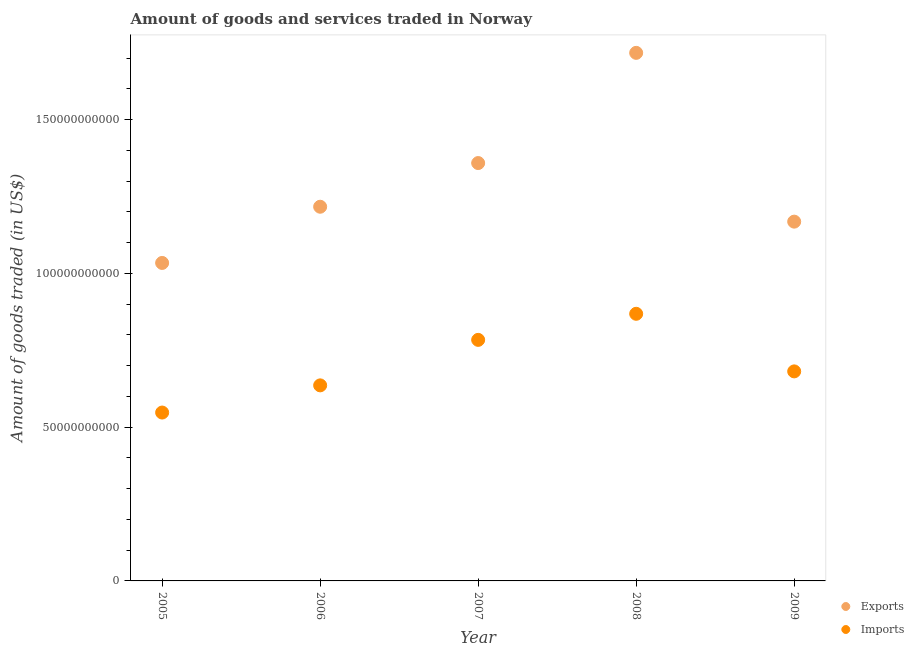How many different coloured dotlines are there?
Keep it short and to the point. 2. Is the number of dotlines equal to the number of legend labels?
Offer a terse response. Yes. What is the amount of goods imported in 2009?
Provide a short and direct response. 6.81e+1. Across all years, what is the maximum amount of goods exported?
Provide a short and direct response. 1.72e+11. Across all years, what is the minimum amount of goods exported?
Keep it short and to the point. 1.03e+11. In which year was the amount of goods imported maximum?
Your answer should be compact. 2008. In which year was the amount of goods exported minimum?
Ensure brevity in your answer.  2005. What is the total amount of goods exported in the graph?
Your response must be concise. 6.49e+11. What is the difference between the amount of goods exported in 2005 and that in 2006?
Offer a very short reply. -1.83e+1. What is the difference between the amount of goods exported in 2007 and the amount of goods imported in 2009?
Provide a succinct answer. 6.77e+1. What is the average amount of goods imported per year?
Provide a succinct answer. 7.03e+1. In the year 2005, what is the difference between the amount of goods exported and amount of goods imported?
Give a very brief answer. 4.86e+1. In how many years, is the amount of goods imported greater than 60000000000 US$?
Provide a short and direct response. 4. What is the ratio of the amount of goods imported in 2005 to that in 2008?
Your answer should be compact. 0.63. Is the amount of goods exported in 2005 less than that in 2009?
Give a very brief answer. Yes. What is the difference between the highest and the second highest amount of goods exported?
Offer a terse response. 3.58e+1. What is the difference between the highest and the lowest amount of goods exported?
Your answer should be compact. 6.83e+1. In how many years, is the amount of goods exported greater than the average amount of goods exported taken over all years?
Give a very brief answer. 2. Is the sum of the amount of goods exported in 2008 and 2009 greater than the maximum amount of goods imported across all years?
Make the answer very short. Yes. Is the amount of goods exported strictly greater than the amount of goods imported over the years?
Keep it short and to the point. Yes. Is the amount of goods imported strictly less than the amount of goods exported over the years?
Your response must be concise. Yes. How many dotlines are there?
Your answer should be very brief. 2. Are the values on the major ticks of Y-axis written in scientific E-notation?
Your answer should be compact. No. Where does the legend appear in the graph?
Ensure brevity in your answer.  Bottom right. What is the title of the graph?
Make the answer very short. Amount of goods and services traded in Norway. Does "Short-term debt" appear as one of the legend labels in the graph?
Your answer should be very brief. No. What is the label or title of the X-axis?
Offer a very short reply. Year. What is the label or title of the Y-axis?
Keep it short and to the point. Amount of goods traded (in US$). What is the Amount of goods traded (in US$) in Exports in 2005?
Provide a short and direct response. 1.03e+11. What is the Amount of goods traded (in US$) of Imports in 2005?
Make the answer very short. 5.47e+1. What is the Amount of goods traded (in US$) of Exports in 2006?
Your response must be concise. 1.22e+11. What is the Amount of goods traded (in US$) in Imports in 2006?
Make the answer very short. 6.36e+1. What is the Amount of goods traded (in US$) in Exports in 2007?
Your answer should be compact. 1.36e+11. What is the Amount of goods traded (in US$) of Imports in 2007?
Keep it short and to the point. 7.84e+1. What is the Amount of goods traded (in US$) of Exports in 2008?
Offer a very short reply. 1.72e+11. What is the Amount of goods traded (in US$) of Imports in 2008?
Provide a short and direct response. 8.68e+1. What is the Amount of goods traded (in US$) in Exports in 2009?
Provide a short and direct response. 1.17e+11. What is the Amount of goods traded (in US$) in Imports in 2009?
Offer a very short reply. 6.81e+1. Across all years, what is the maximum Amount of goods traded (in US$) of Exports?
Give a very brief answer. 1.72e+11. Across all years, what is the maximum Amount of goods traded (in US$) of Imports?
Give a very brief answer. 8.68e+1. Across all years, what is the minimum Amount of goods traded (in US$) of Exports?
Offer a very short reply. 1.03e+11. Across all years, what is the minimum Amount of goods traded (in US$) of Imports?
Offer a terse response. 5.47e+1. What is the total Amount of goods traded (in US$) of Exports in the graph?
Your answer should be very brief. 6.49e+11. What is the total Amount of goods traded (in US$) in Imports in the graph?
Provide a succinct answer. 3.52e+11. What is the difference between the Amount of goods traded (in US$) of Exports in 2005 and that in 2006?
Provide a short and direct response. -1.83e+1. What is the difference between the Amount of goods traded (in US$) of Imports in 2005 and that in 2006?
Your response must be concise. -8.84e+09. What is the difference between the Amount of goods traded (in US$) in Exports in 2005 and that in 2007?
Give a very brief answer. -3.25e+1. What is the difference between the Amount of goods traded (in US$) in Imports in 2005 and that in 2007?
Keep it short and to the point. -2.36e+1. What is the difference between the Amount of goods traded (in US$) in Exports in 2005 and that in 2008?
Your response must be concise. -6.83e+1. What is the difference between the Amount of goods traded (in US$) in Imports in 2005 and that in 2008?
Make the answer very short. -3.21e+1. What is the difference between the Amount of goods traded (in US$) of Exports in 2005 and that in 2009?
Offer a terse response. -1.34e+1. What is the difference between the Amount of goods traded (in US$) in Imports in 2005 and that in 2009?
Give a very brief answer. -1.34e+1. What is the difference between the Amount of goods traded (in US$) of Exports in 2006 and that in 2007?
Offer a very short reply. -1.42e+1. What is the difference between the Amount of goods traded (in US$) in Imports in 2006 and that in 2007?
Your answer should be very brief. -1.48e+1. What is the difference between the Amount of goods traded (in US$) of Exports in 2006 and that in 2008?
Offer a terse response. -5.00e+1. What is the difference between the Amount of goods traded (in US$) of Imports in 2006 and that in 2008?
Make the answer very short. -2.33e+1. What is the difference between the Amount of goods traded (in US$) of Exports in 2006 and that in 2009?
Provide a short and direct response. 4.85e+09. What is the difference between the Amount of goods traded (in US$) in Imports in 2006 and that in 2009?
Your answer should be compact. -4.55e+09. What is the difference between the Amount of goods traded (in US$) in Exports in 2007 and that in 2008?
Give a very brief answer. -3.58e+1. What is the difference between the Amount of goods traded (in US$) in Imports in 2007 and that in 2008?
Your answer should be very brief. -8.48e+09. What is the difference between the Amount of goods traded (in US$) of Exports in 2007 and that in 2009?
Keep it short and to the point. 1.90e+1. What is the difference between the Amount of goods traded (in US$) of Imports in 2007 and that in 2009?
Your response must be concise. 1.02e+1. What is the difference between the Amount of goods traded (in US$) of Exports in 2008 and that in 2009?
Offer a very short reply. 5.49e+1. What is the difference between the Amount of goods traded (in US$) of Imports in 2008 and that in 2009?
Give a very brief answer. 1.87e+1. What is the difference between the Amount of goods traded (in US$) in Exports in 2005 and the Amount of goods traded (in US$) in Imports in 2006?
Keep it short and to the point. 3.98e+1. What is the difference between the Amount of goods traded (in US$) of Exports in 2005 and the Amount of goods traded (in US$) of Imports in 2007?
Your answer should be very brief. 2.50e+1. What is the difference between the Amount of goods traded (in US$) in Exports in 2005 and the Amount of goods traded (in US$) in Imports in 2008?
Give a very brief answer. 1.65e+1. What is the difference between the Amount of goods traded (in US$) in Exports in 2005 and the Amount of goods traded (in US$) in Imports in 2009?
Keep it short and to the point. 3.53e+1. What is the difference between the Amount of goods traded (in US$) in Exports in 2006 and the Amount of goods traded (in US$) in Imports in 2007?
Offer a terse response. 4.33e+1. What is the difference between the Amount of goods traded (in US$) of Exports in 2006 and the Amount of goods traded (in US$) of Imports in 2008?
Provide a succinct answer. 3.48e+1. What is the difference between the Amount of goods traded (in US$) in Exports in 2006 and the Amount of goods traded (in US$) in Imports in 2009?
Your response must be concise. 5.35e+1. What is the difference between the Amount of goods traded (in US$) in Exports in 2007 and the Amount of goods traded (in US$) in Imports in 2008?
Offer a very short reply. 4.90e+1. What is the difference between the Amount of goods traded (in US$) of Exports in 2007 and the Amount of goods traded (in US$) of Imports in 2009?
Your answer should be very brief. 6.77e+1. What is the difference between the Amount of goods traded (in US$) of Exports in 2008 and the Amount of goods traded (in US$) of Imports in 2009?
Offer a very short reply. 1.04e+11. What is the average Amount of goods traded (in US$) of Exports per year?
Your answer should be very brief. 1.30e+11. What is the average Amount of goods traded (in US$) in Imports per year?
Keep it short and to the point. 7.03e+1. In the year 2005, what is the difference between the Amount of goods traded (in US$) in Exports and Amount of goods traded (in US$) in Imports?
Your answer should be compact. 4.86e+1. In the year 2006, what is the difference between the Amount of goods traded (in US$) of Exports and Amount of goods traded (in US$) of Imports?
Provide a short and direct response. 5.81e+1. In the year 2007, what is the difference between the Amount of goods traded (in US$) of Exports and Amount of goods traded (in US$) of Imports?
Provide a short and direct response. 5.75e+1. In the year 2008, what is the difference between the Amount of goods traded (in US$) in Exports and Amount of goods traded (in US$) in Imports?
Provide a short and direct response. 8.48e+1. In the year 2009, what is the difference between the Amount of goods traded (in US$) in Exports and Amount of goods traded (in US$) in Imports?
Provide a succinct answer. 4.87e+1. What is the ratio of the Amount of goods traded (in US$) in Exports in 2005 to that in 2006?
Your answer should be very brief. 0.85. What is the ratio of the Amount of goods traded (in US$) in Imports in 2005 to that in 2006?
Your response must be concise. 0.86. What is the ratio of the Amount of goods traded (in US$) in Exports in 2005 to that in 2007?
Make the answer very short. 0.76. What is the ratio of the Amount of goods traded (in US$) of Imports in 2005 to that in 2007?
Offer a terse response. 0.7. What is the ratio of the Amount of goods traded (in US$) in Exports in 2005 to that in 2008?
Offer a very short reply. 0.6. What is the ratio of the Amount of goods traded (in US$) of Imports in 2005 to that in 2008?
Provide a short and direct response. 0.63. What is the ratio of the Amount of goods traded (in US$) of Exports in 2005 to that in 2009?
Give a very brief answer. 0.89. What is the ratio of the Amount of goods traded (in US$) of Imports in 2005 to that in 2009?
Keep it short and to the point. 0.8. What is the ratio of the Amount of goods traded (in US$) of Exports in 2006 to that in 2007?
Offer a terse response. 0.9. What is the ratio of the Amount of goods traded (in US$) of Imports in 2006 to that in 2007?
Your response must be concise. 0.81. What is the ratio of the Amount of goods traded (in US$) of Exports in 2006 to that in 2008?
Your response must be concise. 0.71. What is the ratio of the Amount of goods traded (in US$) in Imports in 2006 to that in 2008?
Your answer should be compact. 0.73. What is the ratio of the Amount of goods traded (in US$) of Exports in 2006 to that in 2009?
Offer a terse response. 1.04. What is the ratio of the Amount of goods traded (in US$) in Exports in 2007 to that in 2008?
Offer a terse response. 0.79. What is the ratio of the Amount of goods traded (in US$) in Imports in 2007 to that in 2008?
Ensure brevity in your answer.  0.9. What is the ratio of the Amount of goods traded (in US$) of Exports in 2007 to that in 2009?
Your answer should be compact. 1.16. What is the ratio of the Amount of goods traded (in US$) in Imports in 2007 to that in 2009?
Your answer should be very brief. 1.15. What is the ratio of the Amount of goods traded (in US$) of Exports in 2008 to that in 2009?
Your answer should be very brief. 1.47. What is the ratio of the Amount of goods traded (in US$) in Imports in 2008 to that in 2009?
Offer a very short reply. 1.27. What is the difference between the highest and the second highest Amount of goods traded (in US$) of Exports?
Keep it short and to the point. 3.58e+1. What is the difference between the highest and the second highest Amount of goods traded (in US$) of Imports?
Give a very brief answer. 8.48e+09. What is the difference between the highest and the lowest Amount of goods traded (in US$) in Exports?
Make the answer very short. 6.83e+1. What is the difference between the highest and the lowest Amount of goods traded (in US$) of Imports?
Your answer should be very brief. 3.21e+1. 